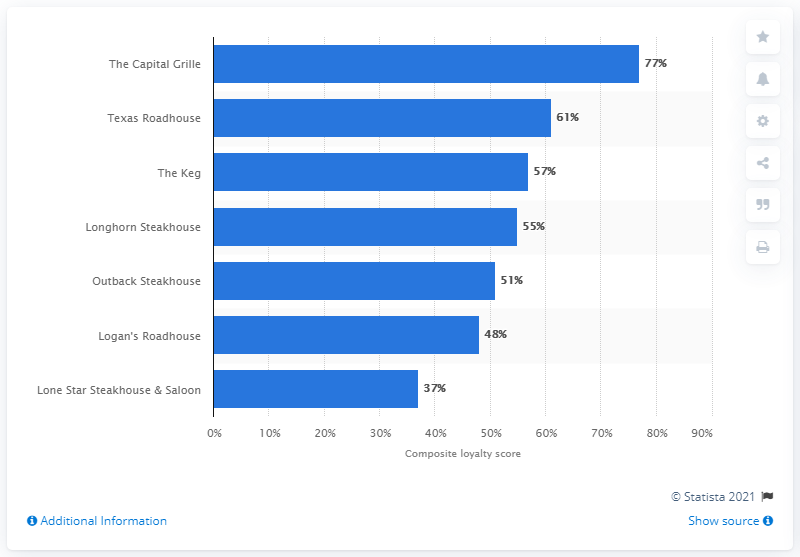Point out several critical features in this image. As of April 2014, The Capital Grille was the most popular steakhouse chain in North America. 